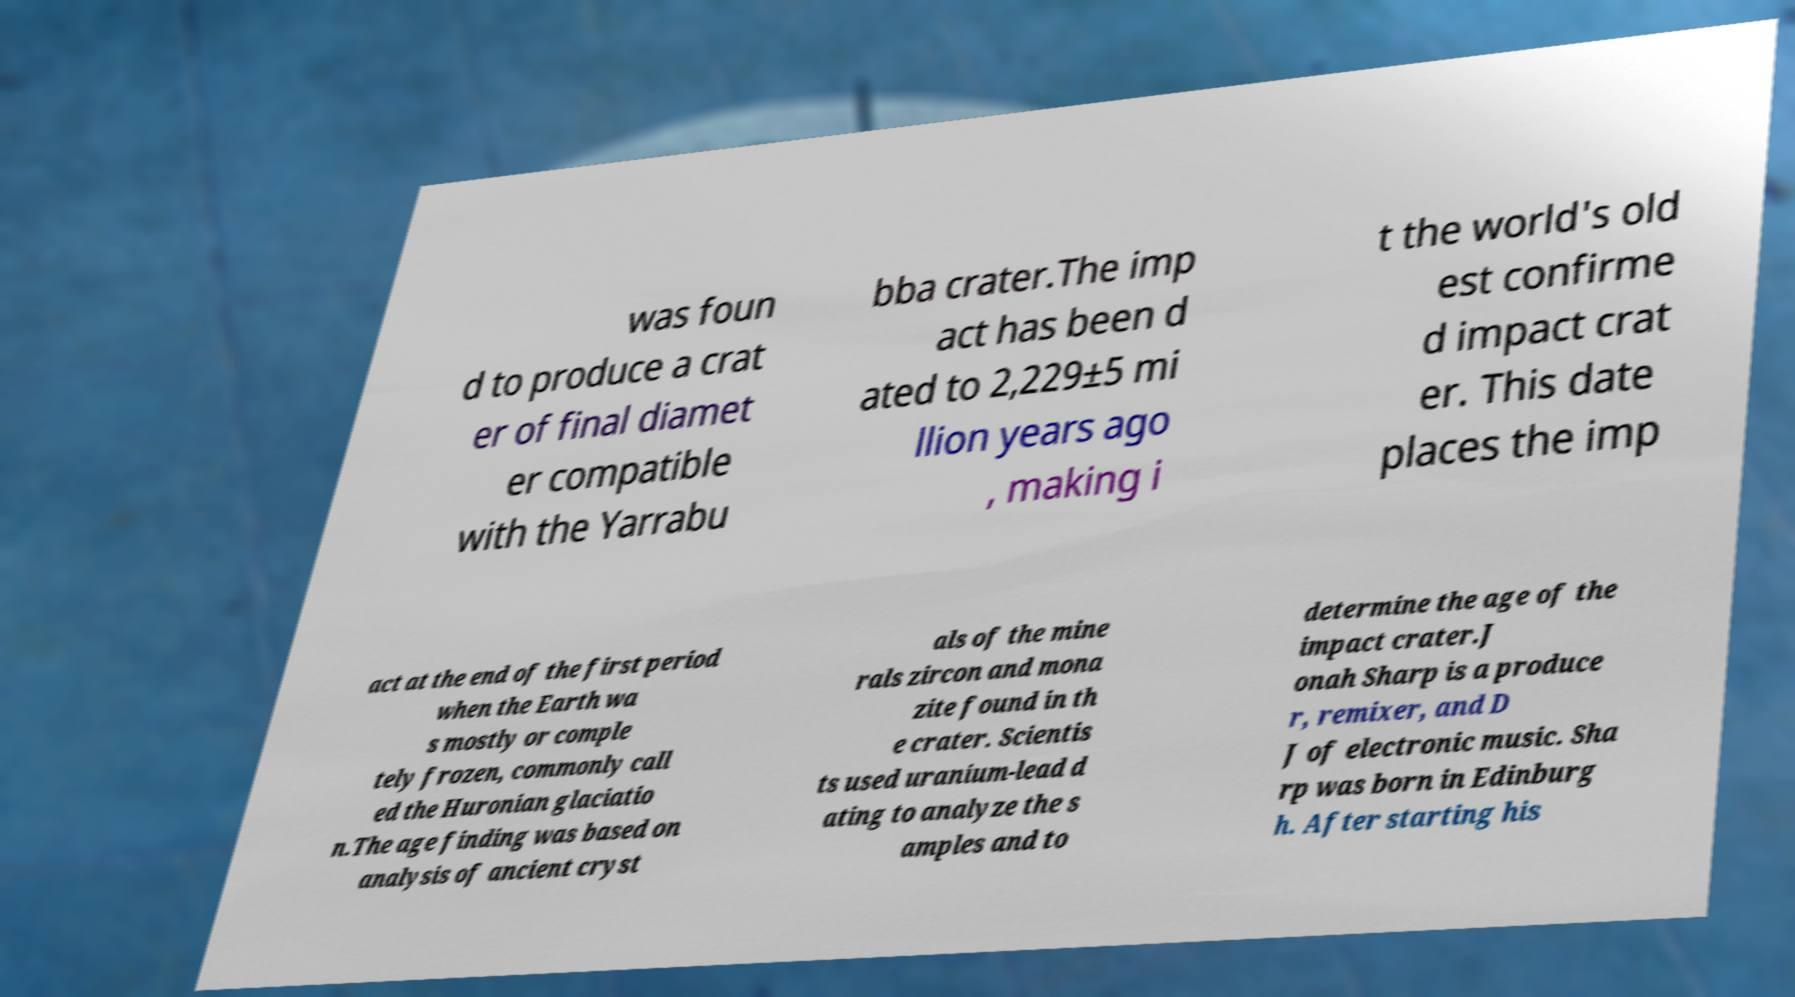Could you assist in decoding the text presented in this image and type it out clearly? was foun d to produce a crat er of final diamet er compatible with the Yarrabu bba crater.The imp act has been d ated to 2,229±5 mi llion years ago , making i t the world's old est confirme d impact crat er. This date places the imp act at the end of the first period when the Earth wa s mostly or comple tely frozen, commonly call ed the Huronian glaciatio n.The age finding was based on analysis of ancient cryst als of the mine rals zircon and mona zite found in th e crater. Scientis ts used uranium-lead d ating to analyze the s amples and to determine the age of the impact crater.J onah Sharp is a produce r, remixer, and D J of electronic music. Sha rp was born in Edinburg h. After starting his 